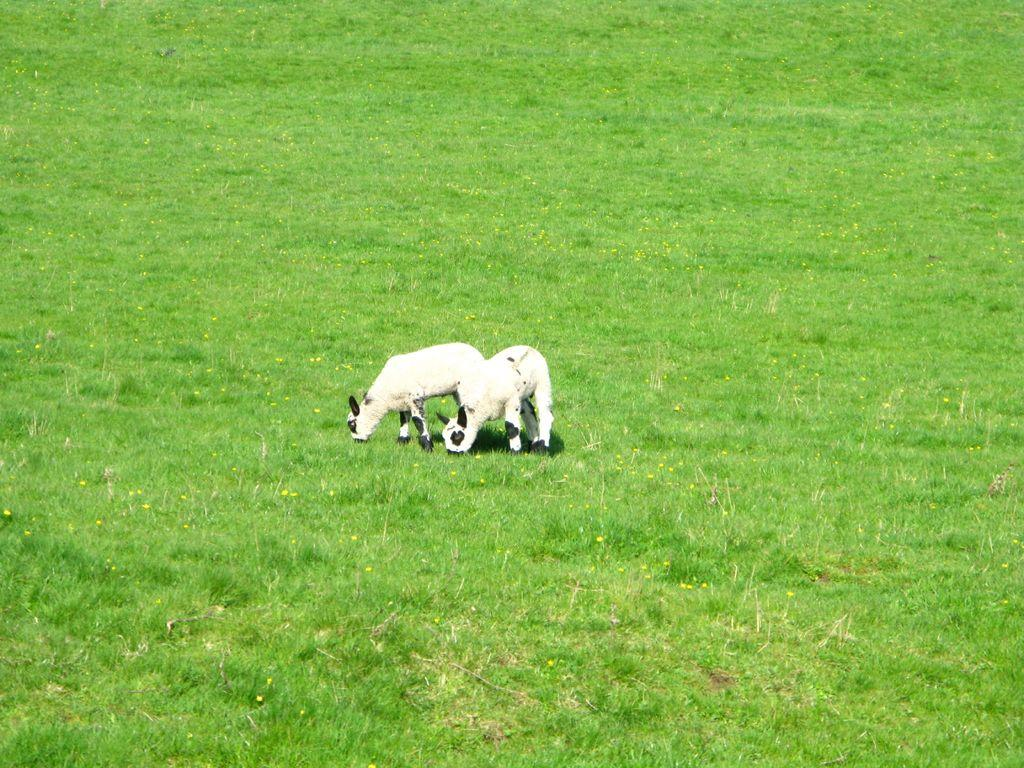How many sheets are visible in the image? There are 2 sheets in the image. What colors are the sheets? The sheets are white and black in color. What type of natural environment is visible in the image? There is green grass visible in the image. How does the earthquake affect the distribution of the sheets in the image? There is no earthquake present in the image, so its effect on the distribution of the sheets cannot be determined. How many bees can be seen interacting with the sheets in the image? There are no bees present in the image; it only features sheets and green grass. 